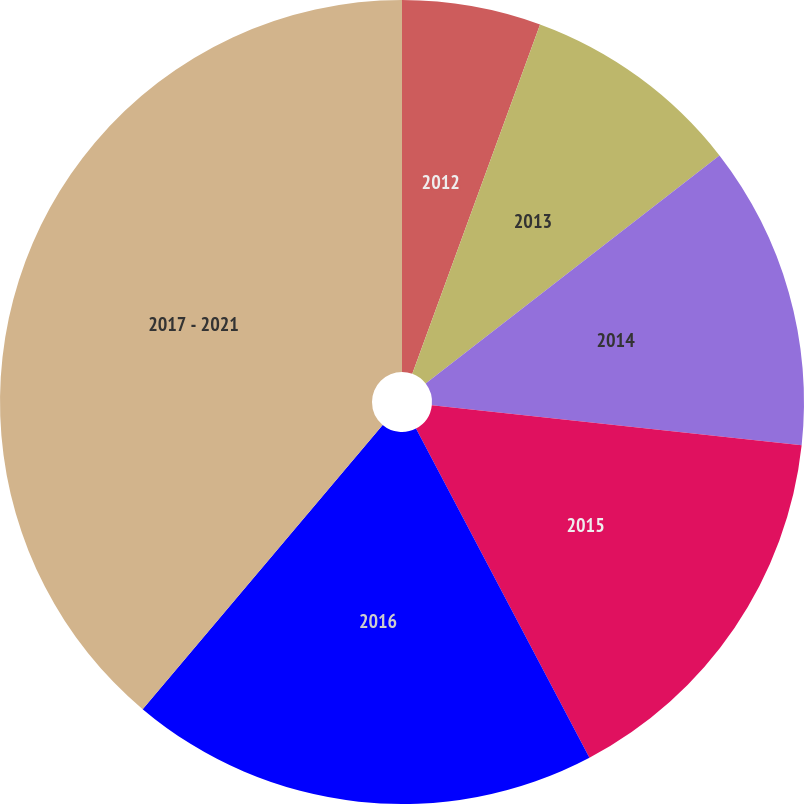<chart> <loc_0><loc_0><loc_500><loc_500><pie_chart><fcel>2012<fcel>2013<fcel>2014<fcel>2015<fcel>2016<fcel>2017 - 2021<nl><fcel>5.58%<fcel>8.91%<fcel>12.23%<fcel>15.56%<fcel>18.88%<fcel>38.84%<nl></chart> 